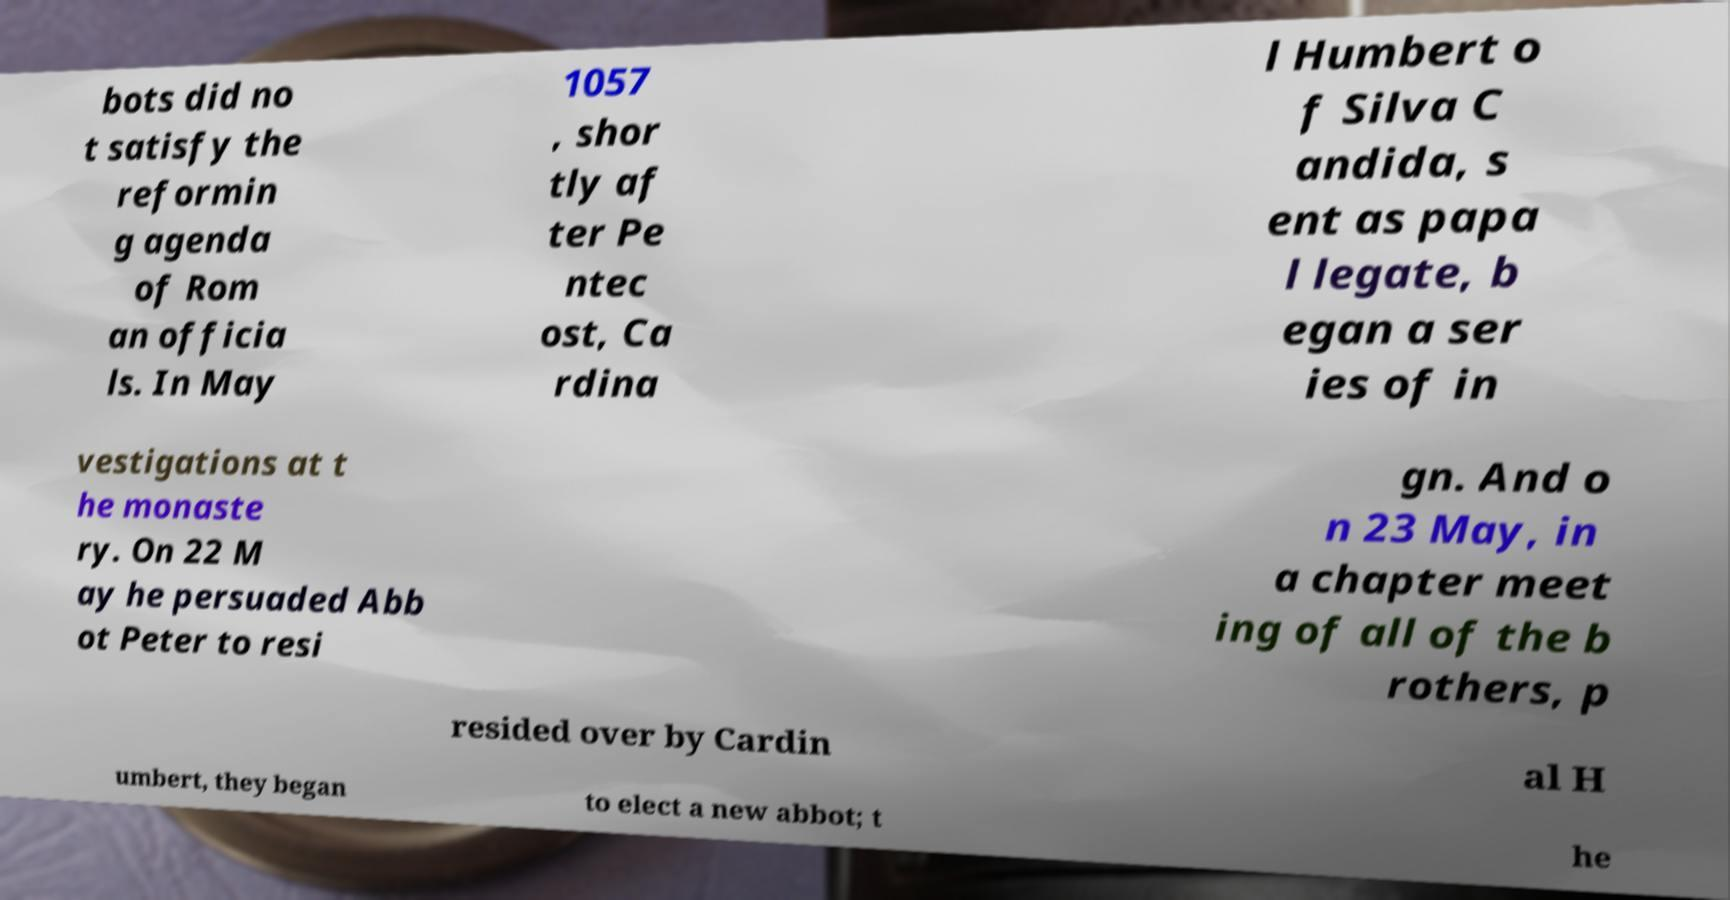Could you extract and type out the text from this image? bots did no t satisfy the reformin g agenda of Rom an officia ls. In May 1057 , shor tly af ter Pe ntec ost, Ca rdina l Humbert o f Silva C andida, s ent as papa l legate, b egan a ser ies of in vestigations at t he monaste ry. On 22 M ay he persuaded Abb ot Peter to resi gn. And o n 23 May, in a chapter meet ing of all of the b rothers, p resided over by Cardin al H umbert, they began to elect a new abbot; t he 